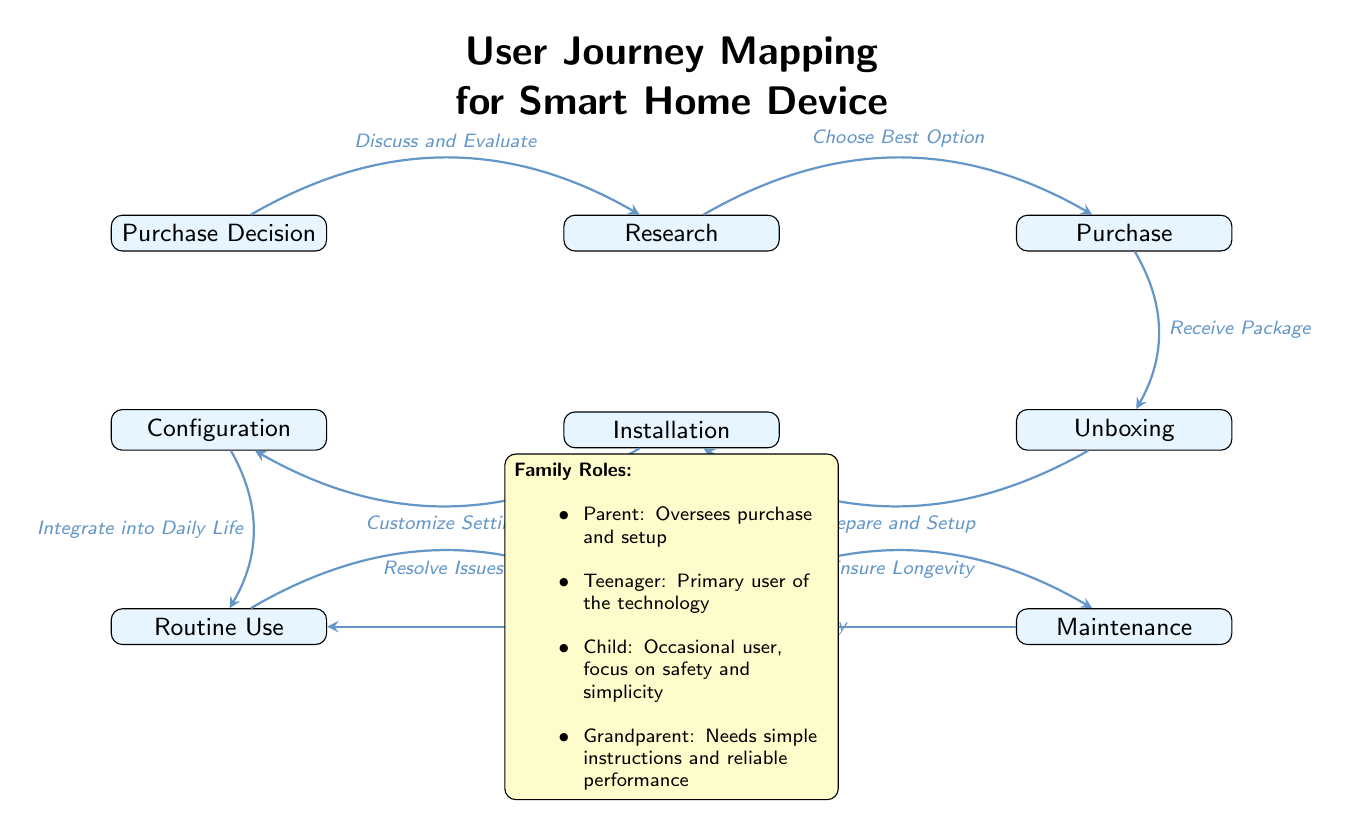What is the first step in the user journey? The diagram indicates that the first step is labeled "Purchase Decision," which starts the user's journey towards integrating the smart home device into their life.
Answer: Purchase Decision How many main states are there in the user journey mapping? Counting the listed nodes in the diagram, we find a total of 9 main states: Purchase Decision, Research, Purchase, Unboxing, Installation, Configuration, Routine Use, Troubleshooting, and Maintenance.
Answer: 9 What follows the "Installation" phase? Directly after the "Installation" phase in the user journey flow of the diagram, the next step indicated is "Configuration." This shows that setting up the device comes before using it.
Answer: Configuration In which phase do family dynamics begin to play a role according to the diagram? The diagram specifies the phase labeled "Routine Use" as when family members actively engage with the smart home device, highlighting how different family roles and dynamics influence interaction during normal usage.
Answer: Routine Use Which family role primarily oversees the purchase and setup of the technology? From the family roles section in the diagram, it is stated that the "Parent" is the family role responsible for overseeing both the purchase and setup of the technology, indicating leadership in these processes.
Answer: Parent How does troubleshooting relate to routine use in the diagram? The diagram illustrates that "Troubleshooting" is a state that follows "Routine Use." This implies that after using the device regularly, issues may arise that need to be addressed, showing a reliance on troubleshooting during ongoing usage.
Answer: Troubleshooting What keyword describes the process of integrating the smart home device into daily life? The diagram emphasizes the keyword "Integrate" in the flow from "Configuration" to "Routine Use," indicating the importance of this step for the user experience with the device.
Answer: Integrate Which family role is identified as needing simple instructions and reliable performance? According to the family roles noted in the diagram, the "Grandparent" is highlighted as needing simple instructions and dependable performance, reflecting considerations for users who may require ease of use due to varying abilities.
Answer: Grandparent What action is required following "Troubleshooting"? The diagram indicates that after "Troubleshooting," users are expected to engage in "Maintenance," implying that users should take steps to ensure the continued functionality of the device after resolving any issues.
Answer: Maintenance 